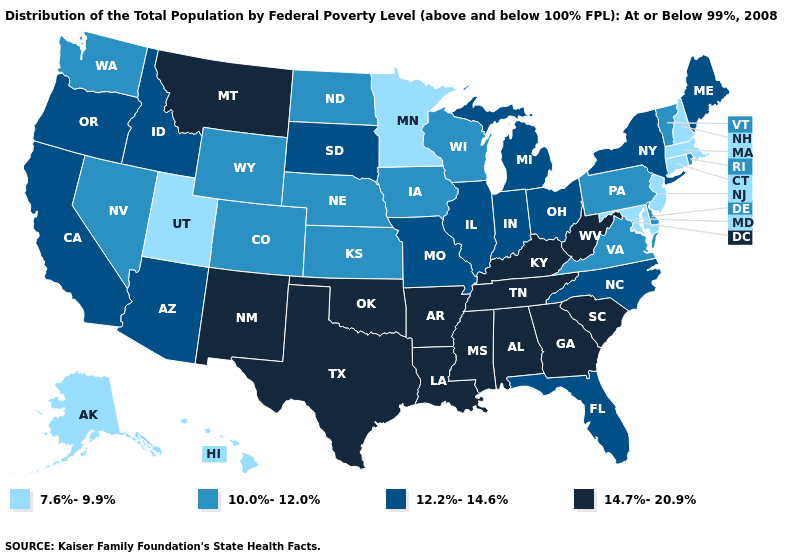Does Alaska have a higher value than Minnesota?
Keep it brief. No. Does Minnesota have the lowest value in the MidWest?
Give a very brief answer. Yes. Name the states that have a value in the range 10.0%-12.0%?
Keep it brief. Colorado, Delaware, Iowa, Kansas, Nebraska, Nevada, North Dakota, Pennsylvania, Rhode Island, Vermont, Virginia, Washington, Wisconsin, Wyoming. What is the value of Idaho?
Write a very short answer. 12.2%-14.6%. Which states hav the highest value in the Northeast?
Answer briefly. Maine, New York. What is the highest value in the MidWest ?
Concise answer only. 12.2%-14.6%. Which states have the lowest value in the South?
Be succinct. Maryland. Does Hawaii have a higher value than Iowa?
Keep it brief. No. Name the states that have a value in the range 7.6%-9.9%?
Quick response, please. Alaska, Connecticut, Hawaii, Maryland, Massachusetts, Minnesota, New Hampshire, New Jersey, Utah. Among the states that border Rhode Island , which have the highest value?
Be succinct. Connecticut, Massachusetts. What is the lowest value in the West?
Give a very brief answer. 7.6%-9.9%. Among the states that border North Dakota , which have the lowest value?
Keep it brief. Minnesota. Name the states that have a value in the range 14.7%-20.9%?
Keep it brief. Alabama, Arkansas, Georgia, Kentucky, Louisiana, Mississippi, Montana, New Mexico, Oklahoma, South Carolina, Tennessee, Texas, West Virginia. Which states have the lowest value in the Northeast?
Be succinct. Connecticut, Massachusetts, New Hampshire, New Jersey. Does the map have missing data?
Quick response, please. No. 